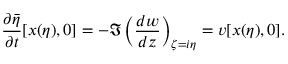<formula> <loc_0><loc_0><loc_500><loc_500>\frac { \partial \bar { \eta } } { \partial t } [ x ( \eta ) , 0 ] = - \Im \left ( \frac { d w } { d z } \right ) _ { \zeta = i \eta } = v [ x ( \eta ) , 0 ] .</formula> 